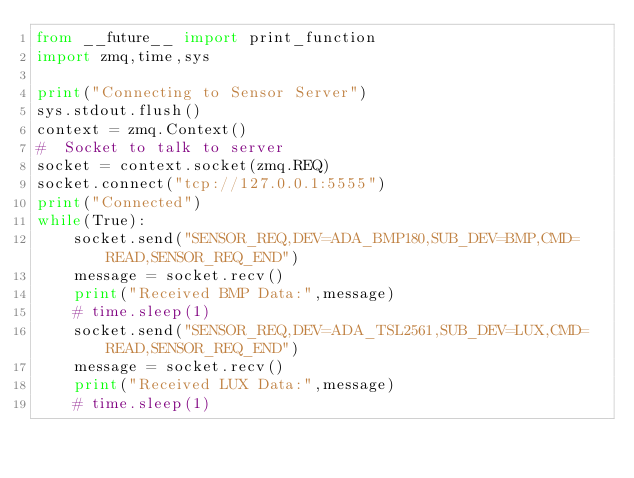Convert code to text. <code><loc_0><loc_0><loc_500><loc_500><_Python_>from __future__ import print_function
import zmq,time,sys
 
print("Connecting to Sensor Server")
sys.stdout.flush()
context = zmq.Context()
#  Socket to talk to server
socket = context.socket(zmq.REQ)
socket.connect("tcp://127.0.0.1:5555")
print("Connected")
while(True):
    socket.send("SENSOR_REQ,DEV=ADA_BMP180,SUB_DEV=BMP,CMD=READ,SENSOR_REQ_END")
    message = socket.recv()
    print("Received BMP Data:",message)
    # time.sleep(1)
    socket.send("SENSOR_REQ,DEV=ADA_TSL2561,SUB_DEV=LUX,CMD=READ,SENSOR_REQ_END")
    message = socket.recv()
    print("Received LUX Data:",message)
    # time.sleep(1)
</code> 